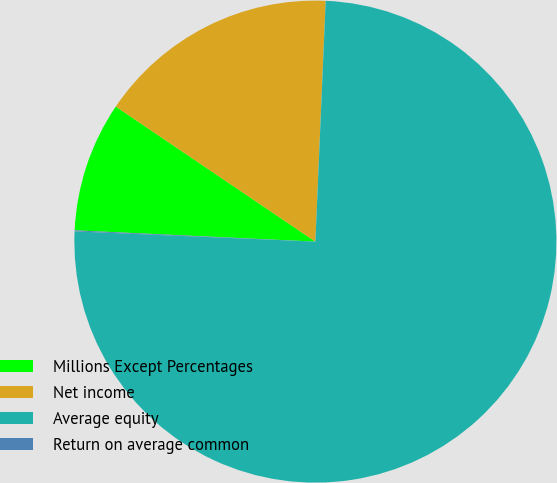Convert chart. <chart><loc_0><loc_0><loc_500><loc_500><pie_chart><fcel>Millions Except Percentages<fcel>Net income<fcel>Average equity<fcel>Return on average common<nl><fcel>8.72%<fcel>16.21%<fcel>74.99%<fcel>0.07%<nl></chart> 